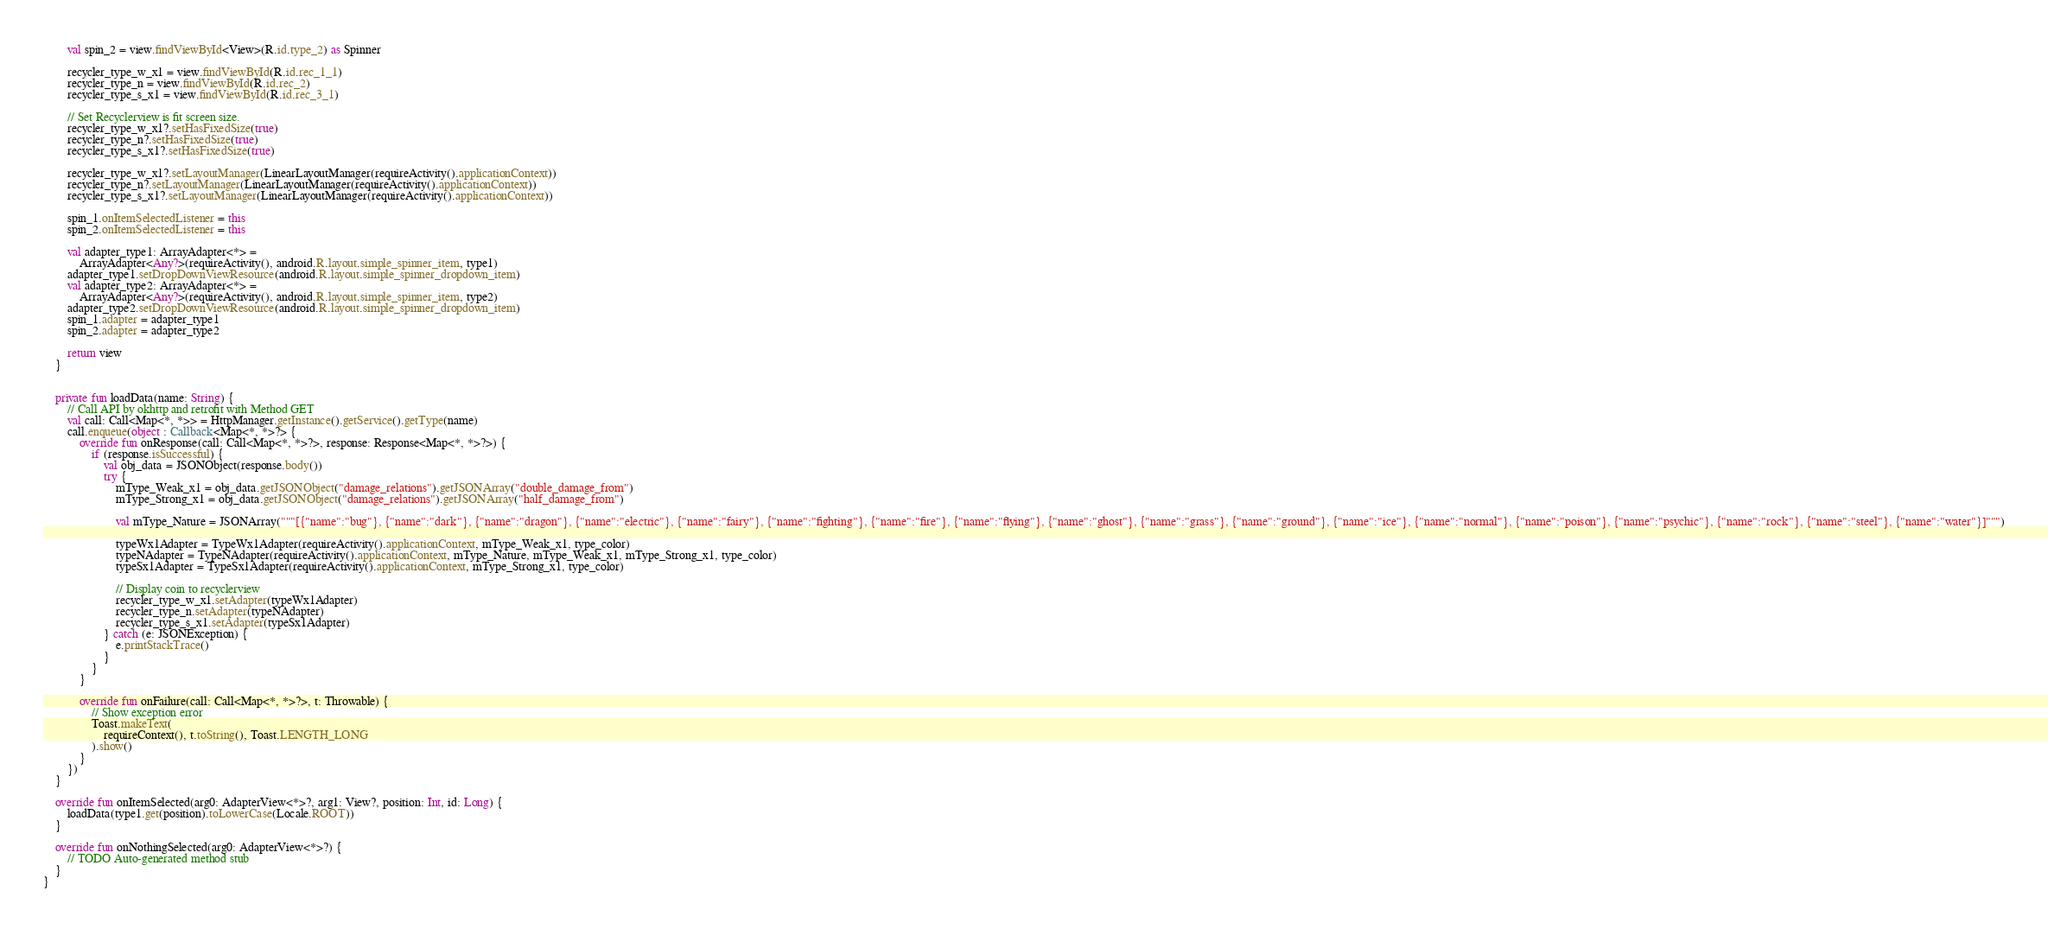Convert code to text. <code><loc_0><loc_0><loc_500><loc_500><_Kotlin_>        val spin_2 = view.findViewById<View>(R.id.type_2) as Spinner

        recycler_type_w_x1 = view.findViewById(R.id.rec_1_1)
        recycler_type_n = view.findViewById(R.id.rec_2)
        recycler_type_s_x1 = view.findViewById(R.id.rec_3_1)

        // Set Recyclerview is fit screen size.
        recycler_type_w_x1?.setHasFixedSize(true)
        recycler_type_n?.setHasFixedSize(true)
        recycler_type_s_x1?.setHasFixedSize(true)

        recycler_type_w_x1?.setLayoutManager(LinearLayoutManager(requireActivity().applicationContext))
        recycler_type_n?.setLayoutManager(LinearLayoutManager(requireActivity().applicationContext))
        recycler_type_s_x1?.setLayoutManager(LinearLayoutManager(requireActivity().applicationContext))

        spin_1.onItemSelectedListener = this
        spin_2.onItemSelectedListener = this

        val adapter_type1: ArrayAdapter<*> =
            ArrayAdapter<Any?>(requireActivity(), android.R.layout.simple_spinner_item, type1)
        adapter_type1.setDropDownViewResource(android.R.layout.simple_spinner_dropdown_item)
        val adapter_type2: ArrayAdapter<*> =
            ArrayAdapter<Any?>(requireActivity(), android.R.layout.simple_spinner_item, type2)
        adapter_type2.setDropDownViewResource(android.R.layout.simple_spinner_dropdown_item)
        spin_1.adapter = adapter_type1
        spin_2.adapter = adapter_type2

        return view
    }


    private fun loadData(name: String) {
        // Call API by okhttp and retrofit with Method GET
        val call: Call<Map<*, *>> = HttpManager.getInstance().getService().getType(name)
        call.enqueue(object : Callback<Map<*, *>?> {
            override fun onResponse(call: Call<Map<*, *>?>, response: Response<Map<*, *>?>) {
                if (response.isSuccessful) {
                    val obj_data = JSONObject(response.body())
                    try {
                        mType_Weak_x1 = obj_data.getJSONObject("damage_relations").getJSONArray("double_damage_from")
                        mType_Strong_x1 = obj_data.getJSONObject("damage_relations").getJSONArray("half_damage_from")

                        val mType_Nature = JSONArray("""[{"name":"bug"}, {"name":"dark"}, {"name":"dragon"}, {"name":"electric"}, {"name":"fairy"}, {"name":"fighting"}, {"name":"fire"}, {"name":"flying"}, {"name":"ghost"}, {"name":"grass"}, {"name":"ground"}, {"name":"ice"}, {"name":"normal"}, {"name":"poison"}, {"name":"psychic"}, {"name":"rock"}, {"name":"steel"}, {"name":"water"}]""")

                        typeWx1Adapter = TypeWx1Adapter(requireActivity().applicationContext, mType_Weak_x1, type_color)
                        typeNAdapter = TypeNAdapter(requireActivity().applicationContext, mType_Nature, mType_Weak_x1, mType_Strong_x1, type_color)
                        typeSx1Adapter = TypeSx1Adapter(requireActivity().applicationContext, mType_Strong_x1, type_color)

                        // Display coin to recyclerview
                        recycler_type_w_x1.setAdapter(typeWx1Adapter)
                        recycler_type_n.setAdapter(typeNAdapter)
                        recycler_type_s_x1.setAdapter(typeSx1Adapter)
                    } catch (e: JSONException) {
                        e.printStackTrace()
                    }
                }
            }

            override fun onFailure(call: Call<Map<*, *>?>, t: Throwable) {
                // Show exception error
                Toast.makeText(
                    requireContext(), t.toString(), Toast.LENGTH_LONG
                ).show()
            }
        })
    }

    override fun onItemSelected(arg0: AdapterView<*>?, arg1: View?, position: Int, id: Long) {
        loadData(type1.get(position).toLowerCase(Locale.ROOT))
    }

    override fun onNothingSelected(arg0: AdapterView<*>?) {
        // TODO Auto-generated method stub
    }
}</code> 